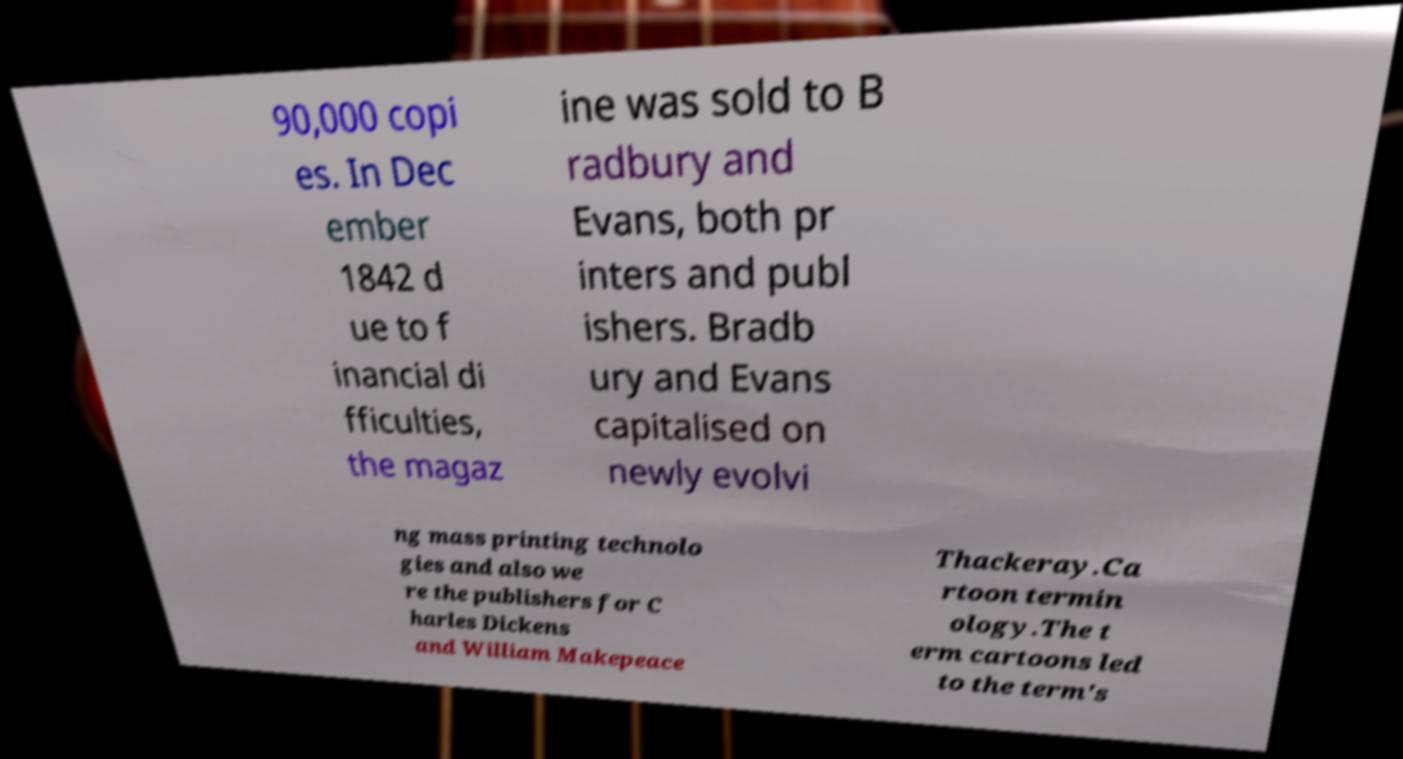Please read and relay the text visible in this image. What does it say? 90,000 copi es. In Dec ember 1842 d ue to f inancial di fficulties, the magaz ine was sold to B radbury and Evans, both pr inters and publ ishers. Bradb ury and Evans capitalised on newly evolvi ng mass printing technolo gies and also we re the publishers for C harles Dickens and William Makepeace Thackeray.Ca rtoon termin ology.The t erm cartoons led to the term's 